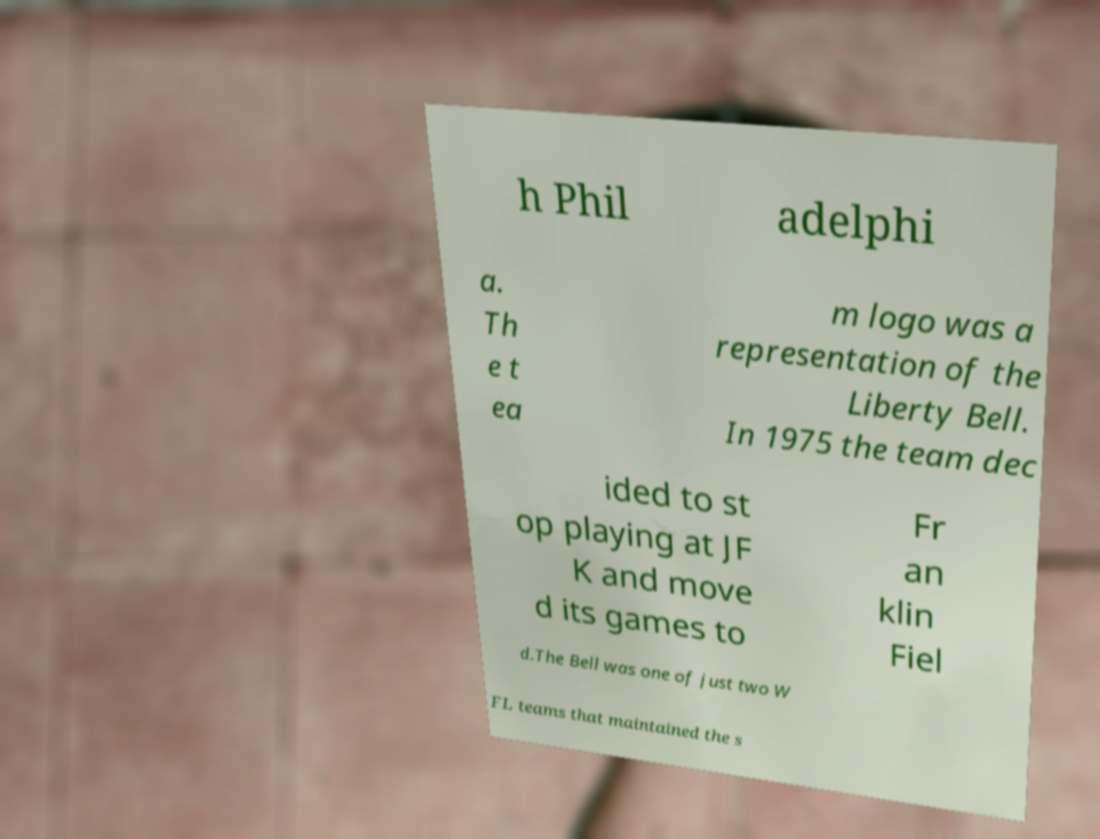Please identify and transcribe the text found in this image. h Phil adelphi a. Th e t ea m logo was a representation of the Liberty Bell. In 1975 the team dec ided to st op playing at JF K and move d its games to Fr an klin Fiel d.The Bell was one of just two W FL teams that maintained the s 